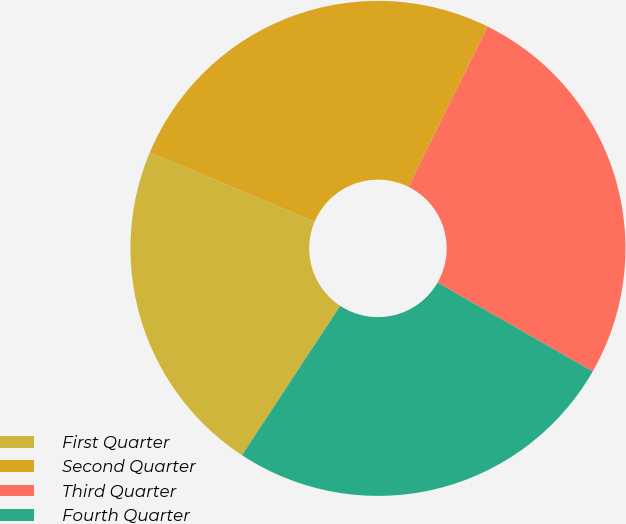Convert chart. <chart><loc_0><loc_0><loc_500><loc_500><pie_chart><fcel>First Quarter<fcel>Second Quarter<fcel>Third Quarter<fcel>Fourth Quarter<nl><fcel>22.08%<fcel>25.97%<fcel>25.97%<fcel>25.97%<nl></chart> 